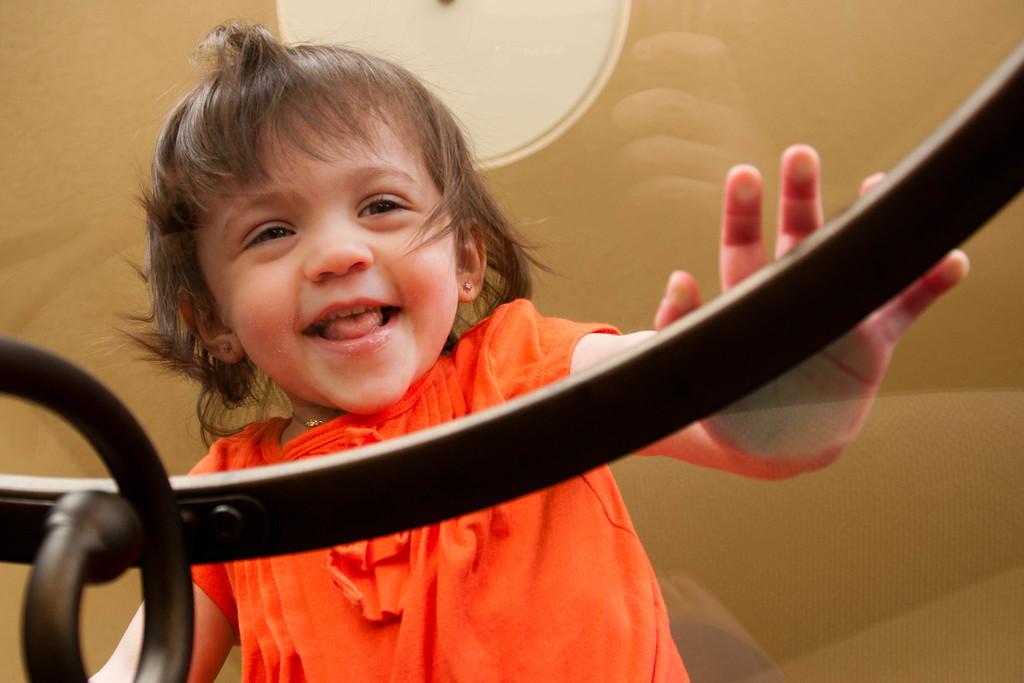How would you summarize this image in a sentence or two? In this picture there is a girl who is wearing orange color dress. She is touching to the glass table. On the top there is a light. 